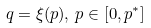<formula> <loc_0><loc_0><loc_500><loc_500>q = \xi ( p ) , \, p \in [ 0 , p ^ { * } ]</formula> 